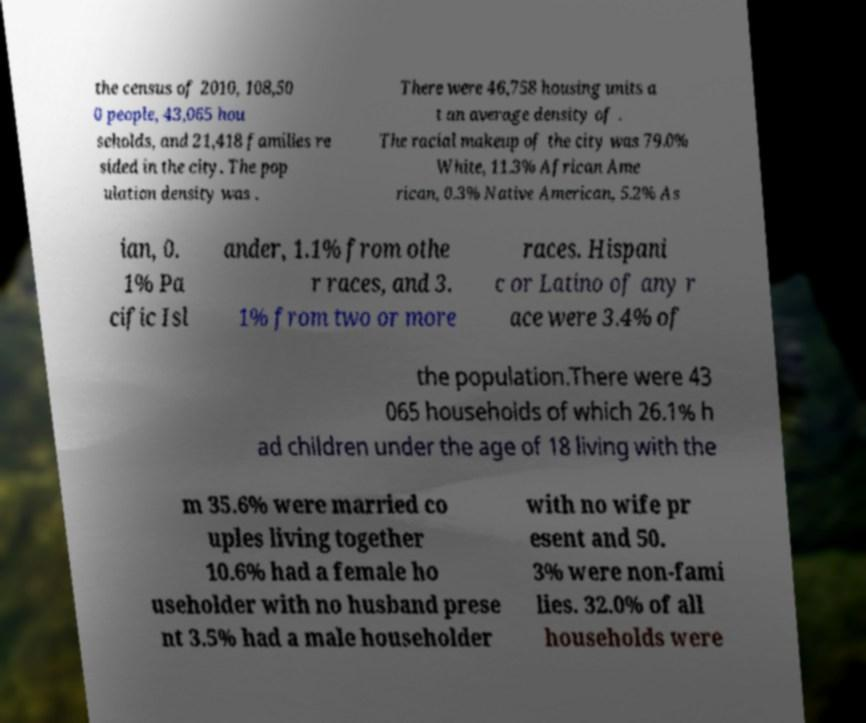Can you read and provide the text displayed in the image?This photo seems to have some interesting text. Can you extract and type it out for me? the census of 2010, 108,50 0 people, 43,065 hou seholds, and 21,418 families re sided in the city. The pop ulation density was . There were 46,758 housing units a t an average density of . The racial makeup of the city was 79.0% White, 11.3% African Ame rican, 0.3% Native American, 5.2% As ian, 0. 1% Pa cific Isl ander, 1.1% from othe r races, and 3. 1% from two or more races. Hispani c or Latino of any r ace were 3.4% of the population.There were 43 065 households of which 26.1% h ad children under the age of 18 living with the m 35.6% were married co uples living together 10.6% had a female ho useholder with no husband prese nt 3.5% had a male householder with no wife pr esent and 50. 3% were non-fami lies. 32.0% of all households were 